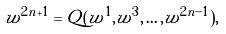<formula> <loc_0><loc_0><loc_500><loc_500>w ^ { 2 n + 1 } = Q ( w ^ { 1 } , w ^ { 3 } , \dots , w ^ { 2 n - 1 } ) ,</formula> 